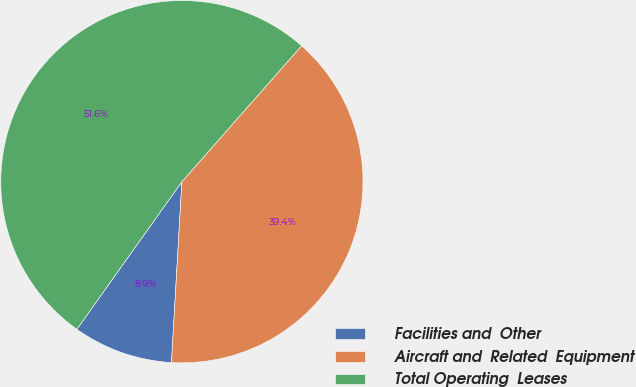Convert chart to OTSL. <chart><loc_0><loc_0><loc_500><loc_500><pie_chart><fcel>Facilities and  Other<fcel>Aircraft and  Related  Equipment<fcel>Total Operating  Leases<nl><fcel>8.93%<fcel>39.42%<fcel>51.64%<nl></chart> 